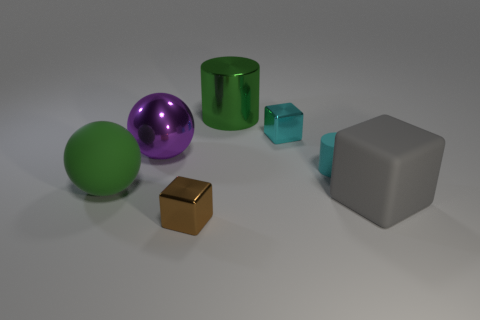Add 1 small cylinders. How many objects exist? 8 Subtract all balls. How many objects are left? 5 Add 6 green things. How many green things are left? 8 Add 1 tiny objects. How many tiny objects exist? 4 Subtract 0 yellow balls. How many objects are left? 7 Subtract all large brown shiny cylinders. Subtract all tiny blocks. How many objects are left? 5 